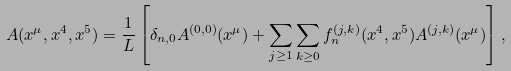<formula> <loc_0><loc_0><loc_500><loc_500>A ( x ^ { \mu } , x ^ { 4 } , x ^ { 5 } ) = \frac { 1 } { L } \left [ \delta _ { n , 0 } A ^ { ( 0 , 0 ) } ( x ^ { \mu } ) + \sum _ { j \geq 1 } \sum _ { k \geq 0 } f _ { n } ^ { ( j , k ) } ( x ^ { 4 } , x ^ { 5 } ) A ^ { ( j , k ) } ( x ^ { \mu } ) \right ] ,</formula> 